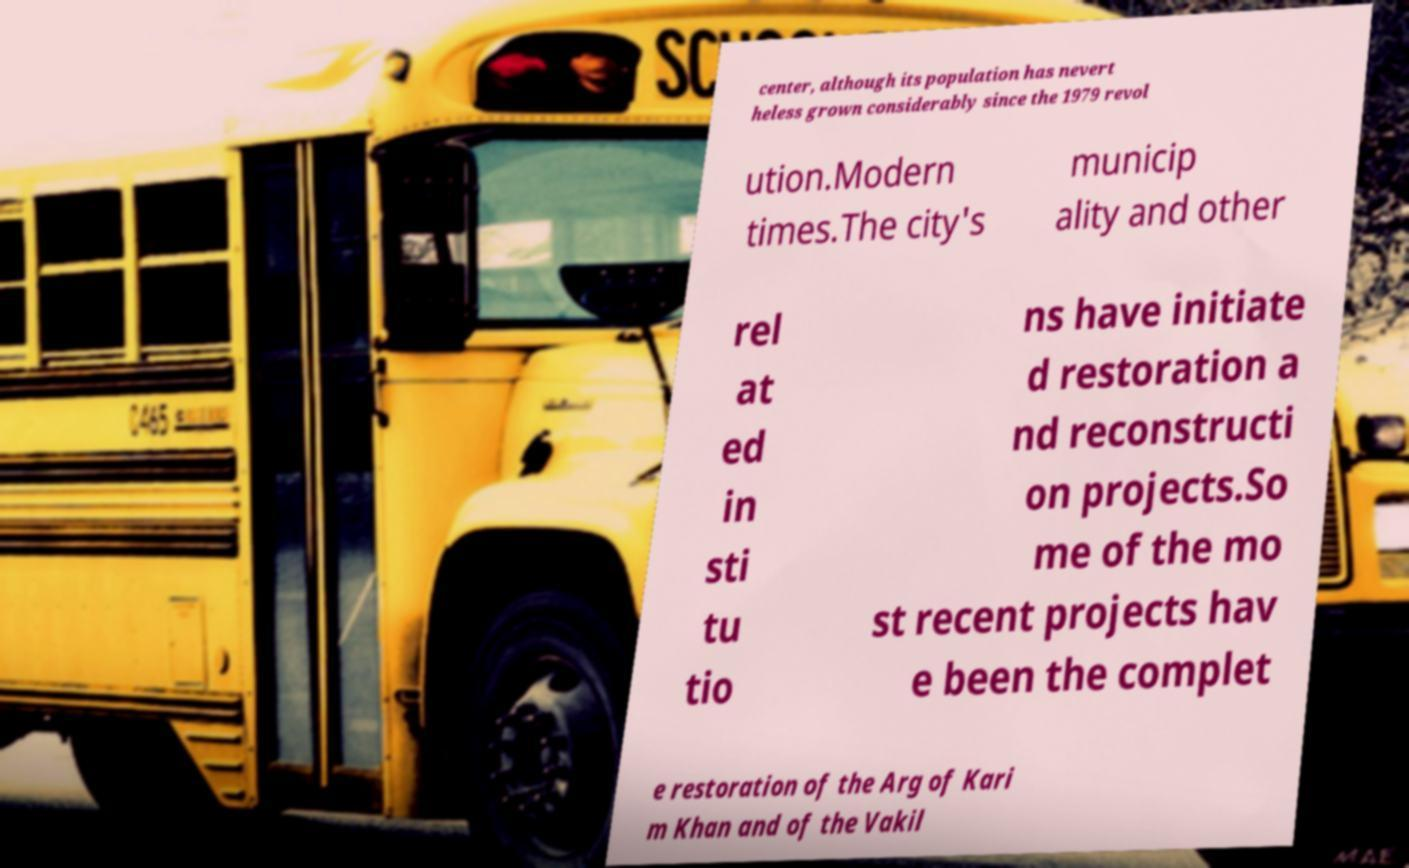I need the written content from this picture converted into text. Can you do that? center, although its population has nevert heless grown considerably since the 1979 revol ution.Modern times.The city's municip ality and other rel at ed in sti tu tio ns have initiate d restoration a nd reconstructi on projects.So me of the mo st recent projects hav e been the complet e restoration of the Arg of Kari m Khan and of the Vakil 